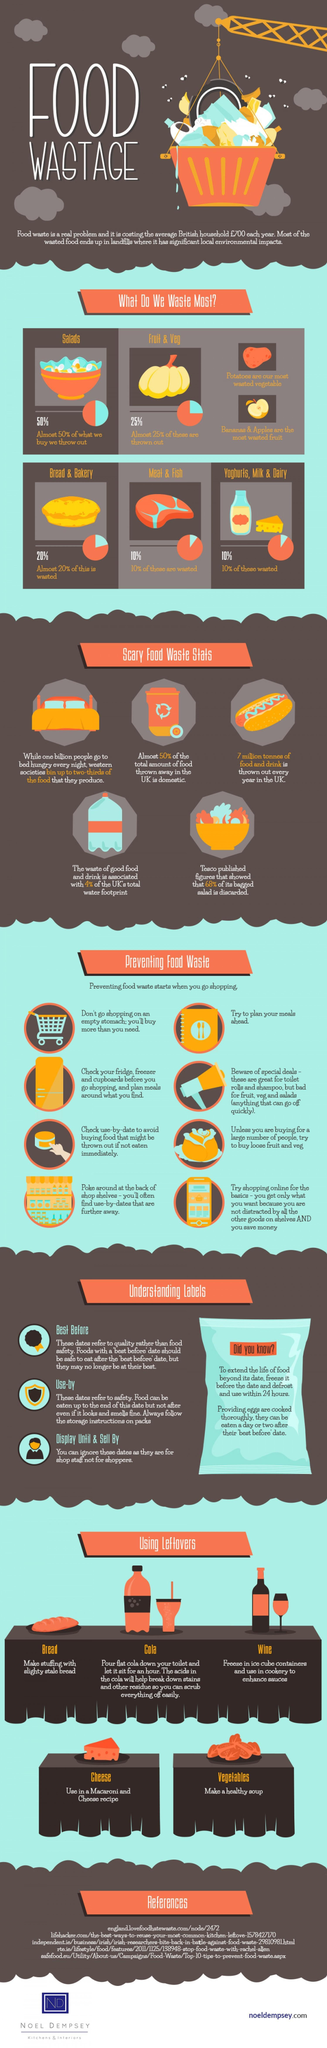What percentage of yogurts, milk, and dairy not wasted?
Answer the question with a short phrase. 90% What are the different labels found on food products? Best before, Use-by, Display until & Sell By Wasting food is prevented in how many ways in this infographic? 8 What percentage of fruit and veg are not thrown out? 75% What percentage of meat and fish not wasted? 90% What percentage of bread and bakery is not wasted? 80% 